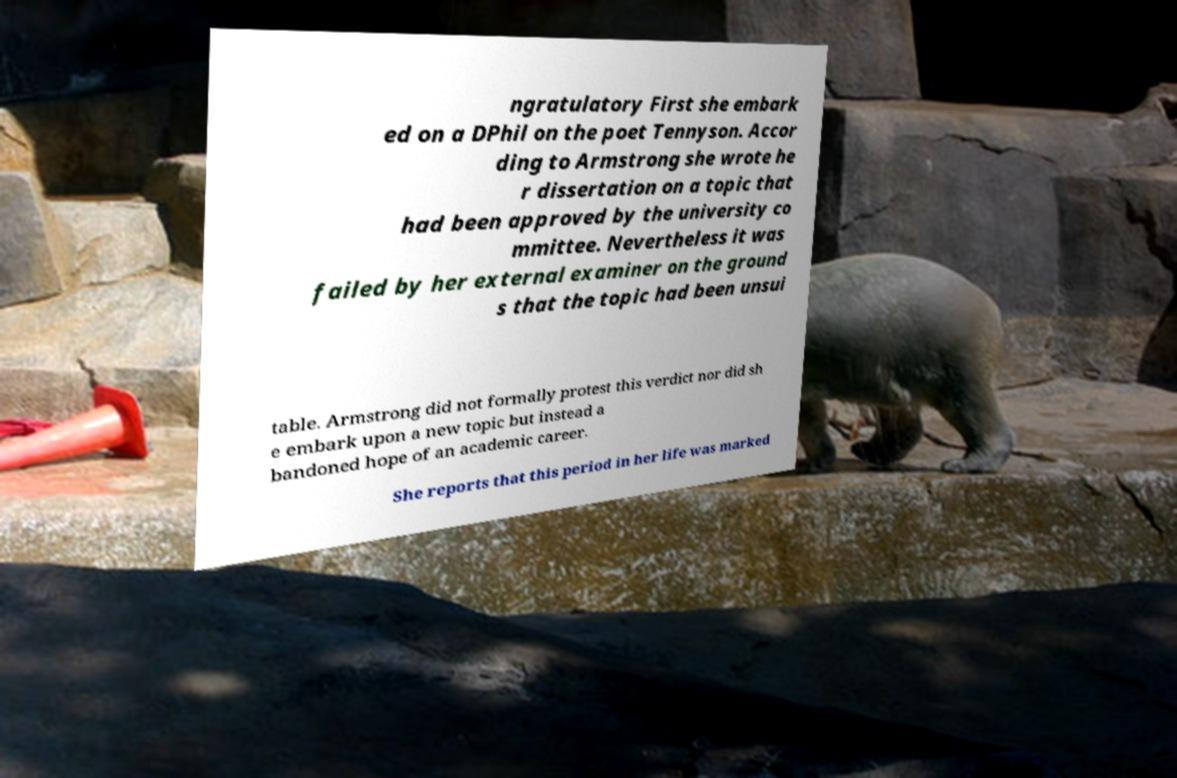For documentation purposes, I need the text within this image transcribed. Could you provide that? ngratulatory First she embark ed on a DPhil on the poet Tennyson. Accor ding to Armstrong she wrote he r dissertation on a topic that had been approved by the university co mmittee. Nevertheless it was failed by her external examiner on the ground s that the topic had been unsui table. Armstrong did not formally protest this verdict nor did sh e embark upon a new topic but instead a bandoned hope of an academic career. She reports that this period in her life was marked 